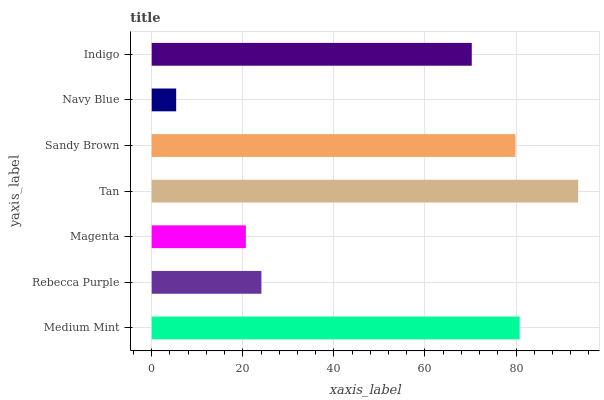Is Navy Blue the minimum?
Answer yes or no. Yes. Is Tan the maximum?
Answer yes or no. Yes. Is Rebecca Purple the minimum?
Answer yes or no. No. Is Rebecca Purple the maximum?
Answer yes or no. No. Is Medium Mint greater than Rebecca Purple?
Answer yes or no. Yes. Is Rebecca Purple less than Medium Mint?
Answer yes or no. Yes. Is Rebecca Purple greater than Medium Mint?
Answer yes or no. No. Is Medium Mint less than Rebecca Purple?
Answer yes or no. No. Is Indigo the high median?
Answer yes or no. Yes. Is Indigo the low median?
Answer yes or no. Yes. Is Navy Blue the high median?
Answer yes or no. No. Is Medium Mint the low median?
Answer yes or no. No. 